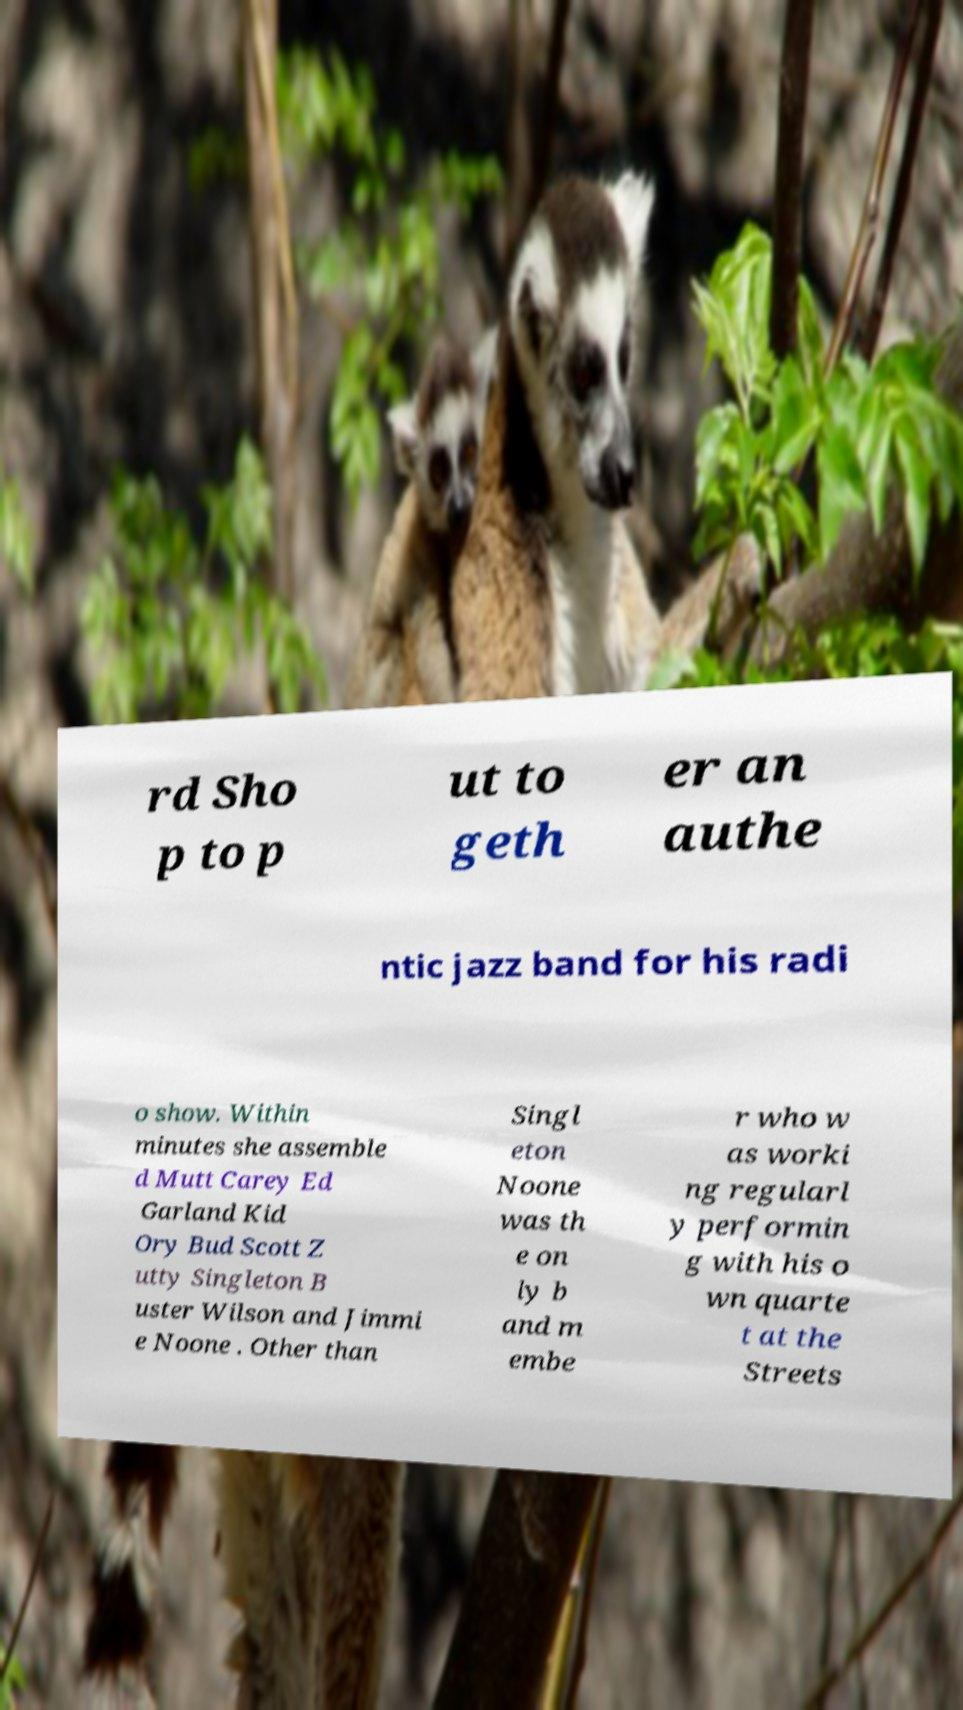Could you assist in decoding the text presented in this image and type it out clearly? rd Sho p to p ut to geth er an authe ntic jazz band for his radi o show. Within minutes she assemble d Mutt Carey Ed Garland Kid Ory Bud Scott Z utty Singleton B uster Wilson and Jimmi e Noone . Other than Singl eton Noone was th e on ly b and m embe r who w as worki ng regularl y performin g with his o wn quarte t at the Streets 